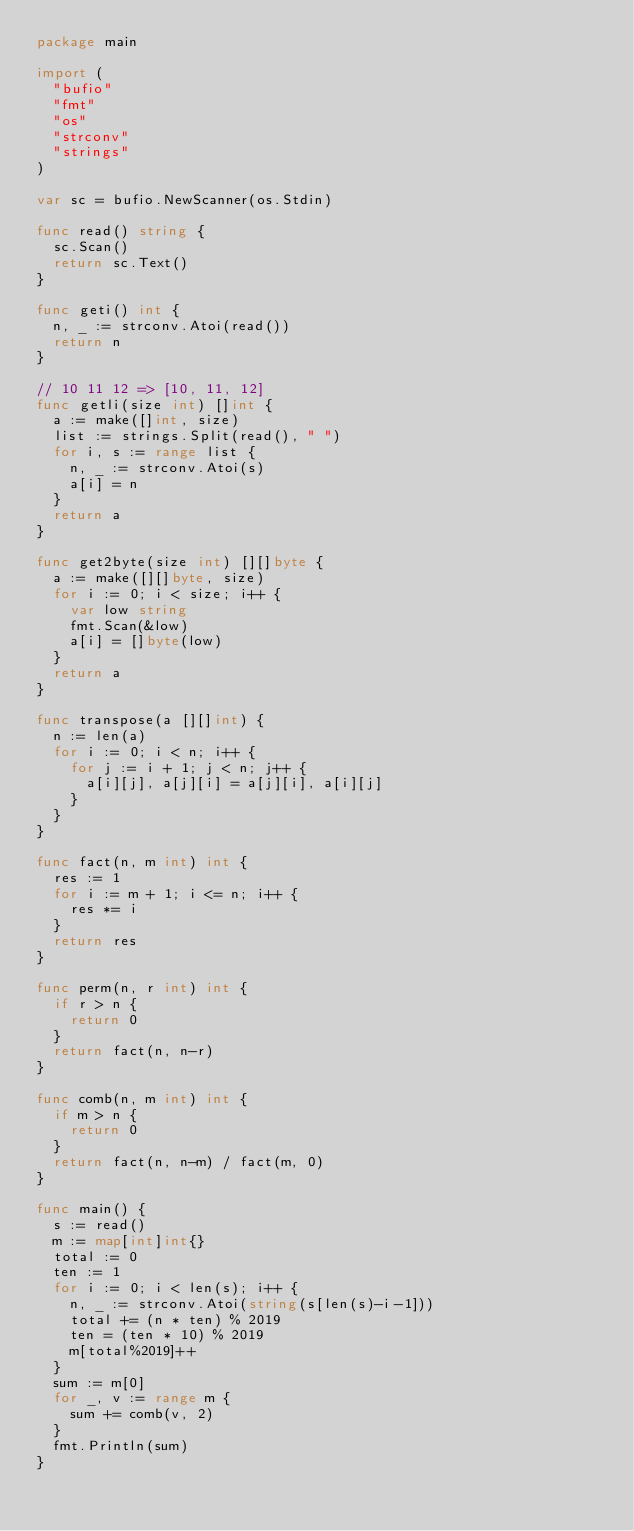Convert code to text. <code><loc_0><loc_0><loc_500><loc_500><_Go_>package main

import (
	"bufio"
	"fmt"
	"os"
	"strconv"
	"strings"
)

var sc = bufio.NewScanner(os.Stdin)

func read() string {
	sc.Scan()
	return sc.Text()
}

func geti() int {
	n, _ := strconv.Atoi(read())
	return n
}

// 10 11 12 => [10, 11, 12]
func getli(size int) []int {
	a := make([]int, size)
	list := strings.Split(read(), " ")
	for i, s := range list {
		n, _ := strconv.Atoi(s)
		a[i] = n
	}
	return a
}

func get2byte(size int) [][]byte {
	a := make([][]byte, size)
	for i := 0; i < size; i++ {
		var low string
		fmt.Scan(&low)
		a[i] = []byte(low)
	}
	return a
}

func transpose(a [][]int) {
	n := len(a)
	for i := 0; i < n; i++ {
		for j := i + 1; j < n; j++ {
			a[i][j], a[j][i] = a[j][i], a[i][j]
		}
	}
}

func fact(n, m int) int {
	res := 1
	for i := m + 1; i <= n; i++ {
		res *= i
	}
	return res
}

func perm(n, r int) int {
	if r > n {
		return 0
	}
	return fact(n, n-r)
}

func comb(n, m int) int {
	if m > n {
		return 0
	}
	return fact(n, n-m) / fact(m, 0)
}

func main() {
	s := read()
	m := map[int]int{}
	total := 0
	ten := 1
	for i := 0; i < len(s); i++ {
		n, _ := strconv.Atoi(string(s[len(s)-i-1]))
		total += (n * ten) % 2019
		ten = (ten * 10) % 2019
		m[total%2019]++
	}
	sum := m[0]
	for _, v := range m {
		sum += comb(v, 2)
	}
	fmt.Println(sum)
}
</code> 